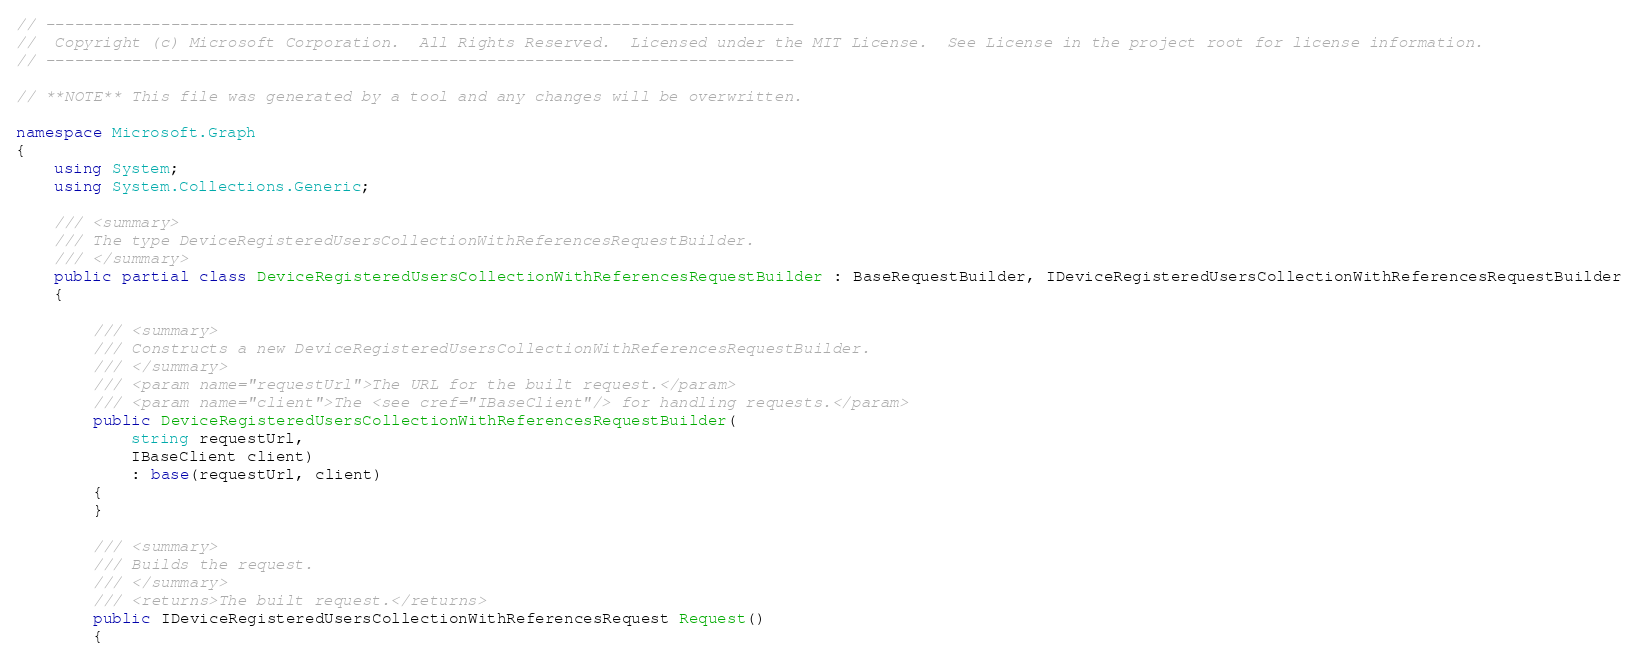Convert code to text. <code><loc_0><loc_0><loc_500><loc_500><_C#_>// ------------------------------------------------------------------------------
//  Copyright (c) Microsoft Corporation.  All Rights Reserved.  Licensed under the MIT License.  See License in the project root for license information.
// ------------------------------------------------------------------------------

// **NOTE** This file was generated by a tool and any changes will be overwritten.

namespace Microsoft.Graph
{
    using System;
    using System.Collections.Generic;

    /// <summary>
    /// The type DeviceRegisteredUsersCollectionWithReferencesRequestBuilder.
    /// </summary>
    public partial class DeviceRegisteredUsersCollectionWithReferencesRequestBuilder : BaseRequestBuilder, IDeviceRegisteredUsersCollectionWithReferencesRequestBuilder
    {

        /// <summary>
        /// Constructs a new DeviceRegisteredUsersCollectionWithReferencesRequestBuilder.
        /// </summary>
        /// <param name="requestUrl">The URL for the built request.</param>
        /// <param name="client">The <see cref="IBaseClient"/> for handling requests.</param>
        public DeviceRegisteredUsersCollectionWithReferencesRequestBuilder(
            string requestUrl,
            IBaseClient client)
            : base(requestUrl, client)
        {
        }

        /// <summary>
        /// Builds the request.
        /// </summary>
        /// <returns>The built request.</returns>
        public IDeviceRegisteredUsersCollectionWithReferencesRequest Request()
        {</code> 